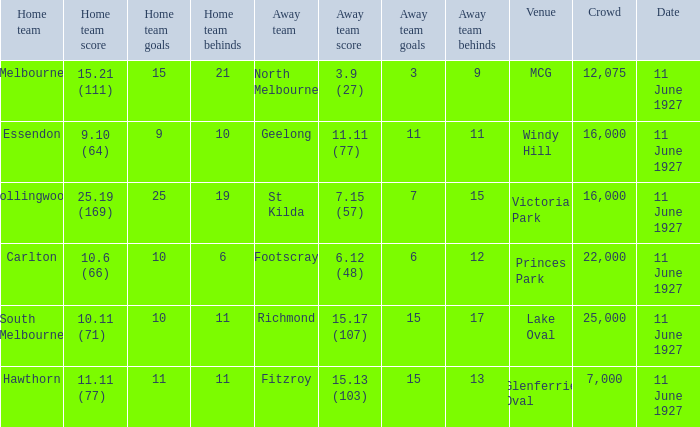At the mcg venue, how many individuals were there in all the gathered crowds combined? 12075.0. 